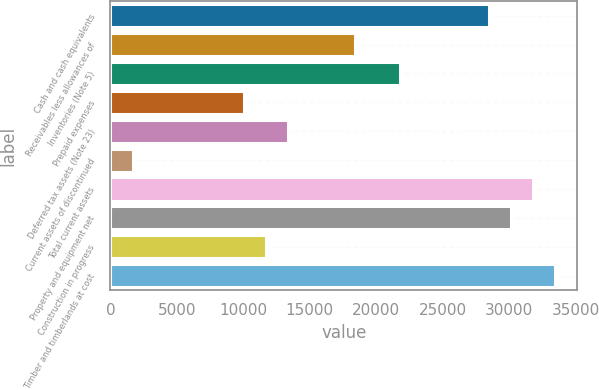Convert chart to OTSL. <chart><loc_0><loc_0><loc_500><loc_500><bar_chart><fcel>Cash and cash equivalents<fcel>Receivables less allowances of<fcel>Inventories (Note 5)<fcel>Prepaid expenses<fcel>Deferred tax assets (Note 23)<fcel>Current assets of discontinued<fcel>Total current assets<fcel>Property and equipment net<fcel>Construction in progress<fcel>Timber and timberlands at cost<nl><fcel>28441.8<fcel>18407.4<fcel>21752.2<fcel>10045.4<fcel>13390.2<fcel>1683.4<fcel>31786.6<fcel>30114.2<fcel>11717.8<fcel>33459<nl></chart> 